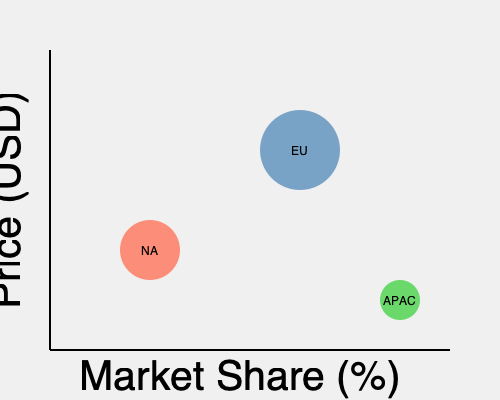As a business consultant, analyze the bubble chart representing pricing strategies across different regions for a global snack product. Which region appears to have the most effective pricing strategy in terms of balancing market share and price, and why might this be particularly relevant for a company like Mondelēz International? To analyze the pricing strategies across regions, we need to consider both the price (y-axis) and market share (x-axis) for each region, as well as the size of the bubble, which typically represents sales volume. Let's break down the analysis step-by-step:

1. North America (NA):
   - Medium price point
   - Relatively low market share
   - Medium sales volume

2. Europe (EU):
   - Highest price point
   - Medium market share
   - Largest sales volume

3. Asia-Pacific (APAC):
   - Lowest price point
   - Highest market share
   - Smallest sales volume

The most effective pricing strategy balances price and market share to maximize revenue and profitability. In this case, the European (EU) region appears to have the most effective strategy because:

a) It maintains the highest price point, suggesting premium positioning or higher perceived value.
b) It has a solid market share, indicating good consumer acceptance despite the higher price.
c) It has the largest sales volume (biggest bubble), implying that the higher price hasn't significantly deterred purchases.

This strategy is particularly relevant for a company like Mondelēz International because:

1. Premium positioning: As a global snack company, Mondelēz often focuses on brand value and product quality, which aligns with higher pricing strategies.

2. Market diversity: The chart shows how different regions respond to various pricing strategies, highlighting the importance of tailored approaches in a global market.

3. Volume-driven business: Snack foods often rely on high sales volumes, and the EU strategy demonstrates success in maintaining volume while commanding a higher price.

4. Profit margins: Higher prices in the EU, combined with large sales volumes, likely contribute to better profit margins, which is crucial for a publicly-traded company like Mondelēz.

5. Brand strength: The ability to charge higher prices while maintaining market share and volume suggests strong brand equity, a key asset for Mondelēz's portfolio of well-known brands.

Understanding these regional differences can help in developing targeted strategies for each market, potentially applying successful elements from the EU approach to other regions where appropriate.
Answer: Europe (EU), due to its high price point, solid market share, and largest sales volume, balancing premium positioning with strong consumer demand. 